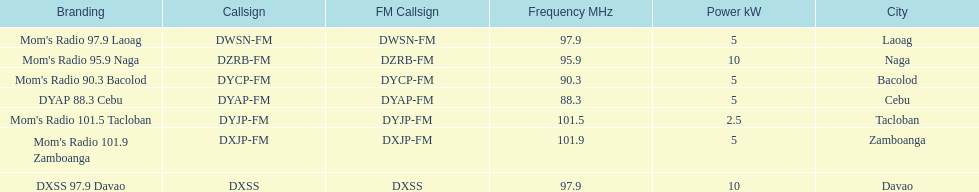How many stations have at least 5 kw or more listed in the power column? 6. 